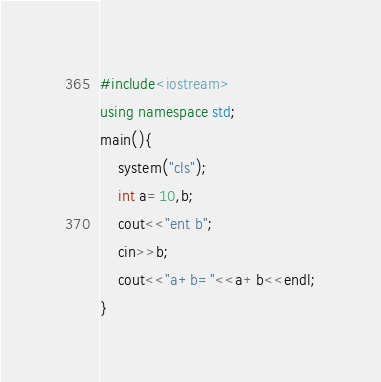<code> <loc_0><loc_0><loc_500><loc_500><_C++_>#include<iostream>
using namespace std;
main(){
    system("cls");
    int a=10,b;
    cout<<"ent b";
    cin>>b;
    cout<<"a+b="<<a+b<<endl;
}
</code> 